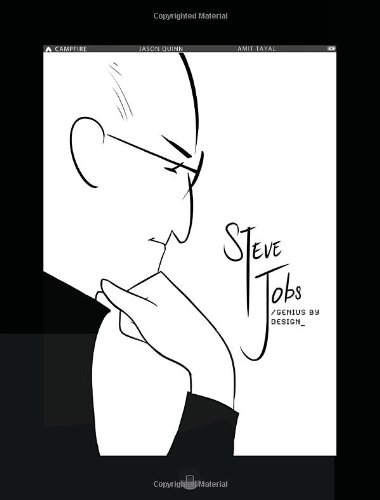What is the title of this book? The full title of this graphical biography is 'Steve Jobs: Genius by Design: Campfire Biography-Heroes Line (Campfire Graphic Novels)', offering insights into Steve Jobs' life and achievements. 